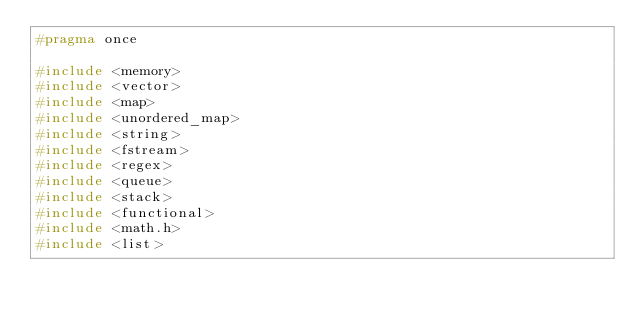<code> <loc_0><loc_0><loc_500><loc_500><_C_>#pragma once

#include <memory>
#include <vector>
#include <map>
#include <unordered_map>
#include <string>
#include <fstream>
#include <regex>
#include <queue>
#include <stack>
#include <functional>
#include <math.h>
#include <list></code> 